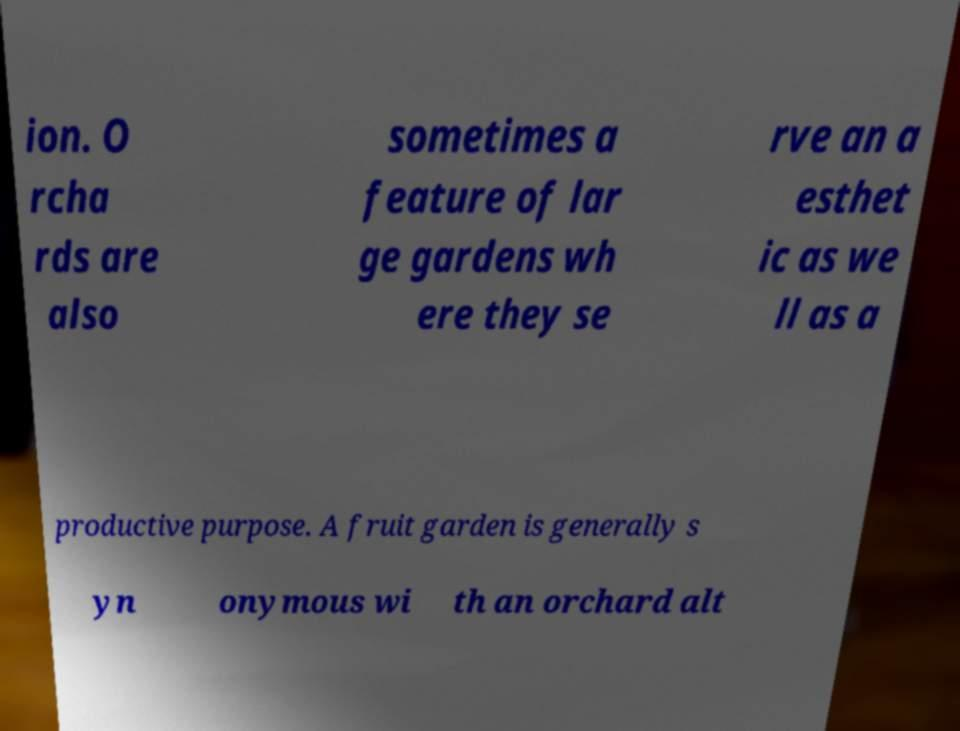Can you read and provide the text displayed in the image?This photo seems to have some interesting text. Can you extract and type it out for me? ion. O rcha rds are also sometimes a feature of lar ge gardens wh ere they se rve an a esthet ic as we ll as a productive purpose. A fruit garden is generally s yn onymous wi th an orchard alt 